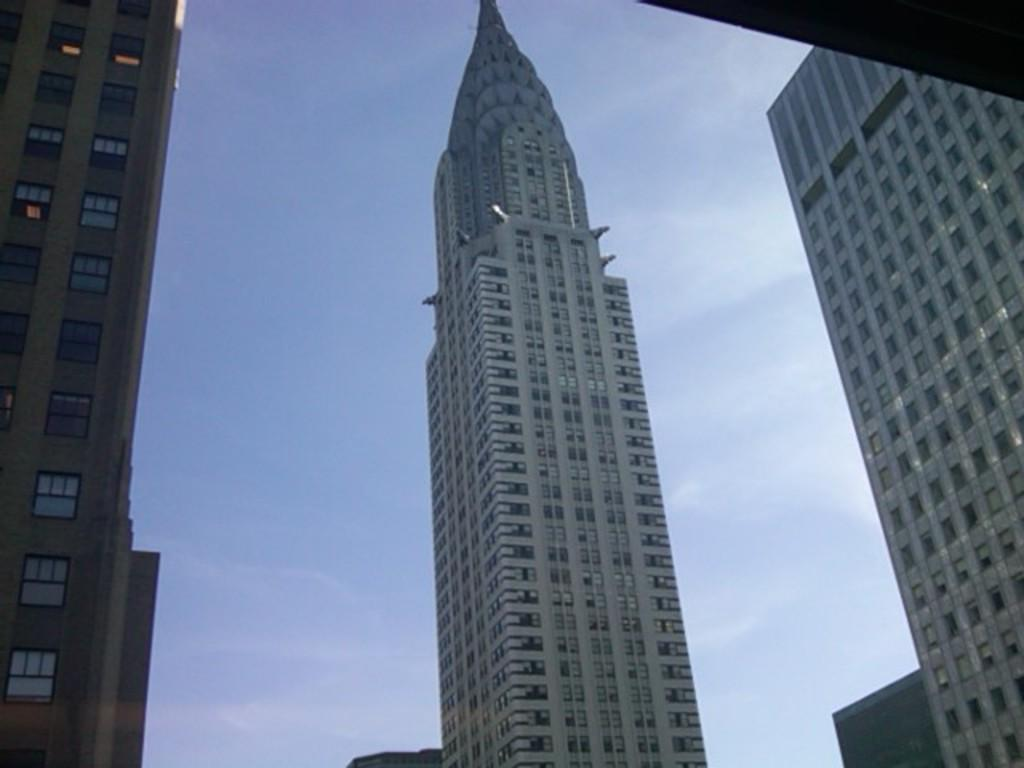How many buildings can be seen in the front of the image? There are three buildings in the front of the image. What can be seen in the background of the image? The sky is visible in the background of the image. What type of finger can be seen holding a cup in the image? There is no finger or cup present in the image; it only features three buildings and the sky. 